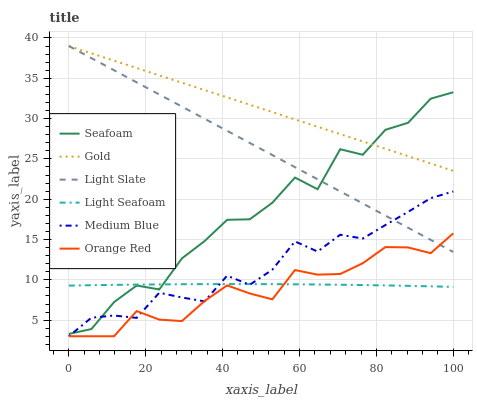Does Orange Red have the minimum area under the curve?
Answer yes or no. Yes. Does Gold have the maximum area under the curve?
Answer yes or no. Yes. Does Light Slate have the minimum area under the curve?
Answer yes or no. No. Does Light Slate have the maximum area under the curve?
Answer yes or no. No. Is Light Slate the smoothest?
Answer yes or no. Yes. Is Seafoam the roughest?
Answer yes or no. Yes. Is Medium Blue the smoothest?
Answer yes or no. No. Is Medium Blue the roughest?
Answer yes or no. No. Does Medium Blue have the lowest value?
Answer yes or no. Yes. Does Light Slate have the lowest value?
Answer yes or no. No. Does Light Slate have the highest value?
Answer yes or no. Yes. Does Medium Blue have the highest value?
Answer yes or no. No. Is Light Seafoam less than Light Slate?
Answer yes or no. Yes. Is Gold greater than Light Seafoam?
Answer yes or no. Yes. Does Orange Red intersect Light Seafoam?
Answer yes or no. Yes. Is Orange Red less than Light Seafoam?
Answer yes or no. No. Is Orange Red greater than Light Seafoam?
Answer yes or no. No. Does Light Seafoam intersect Light Slate?
Answer yes or no. No. 